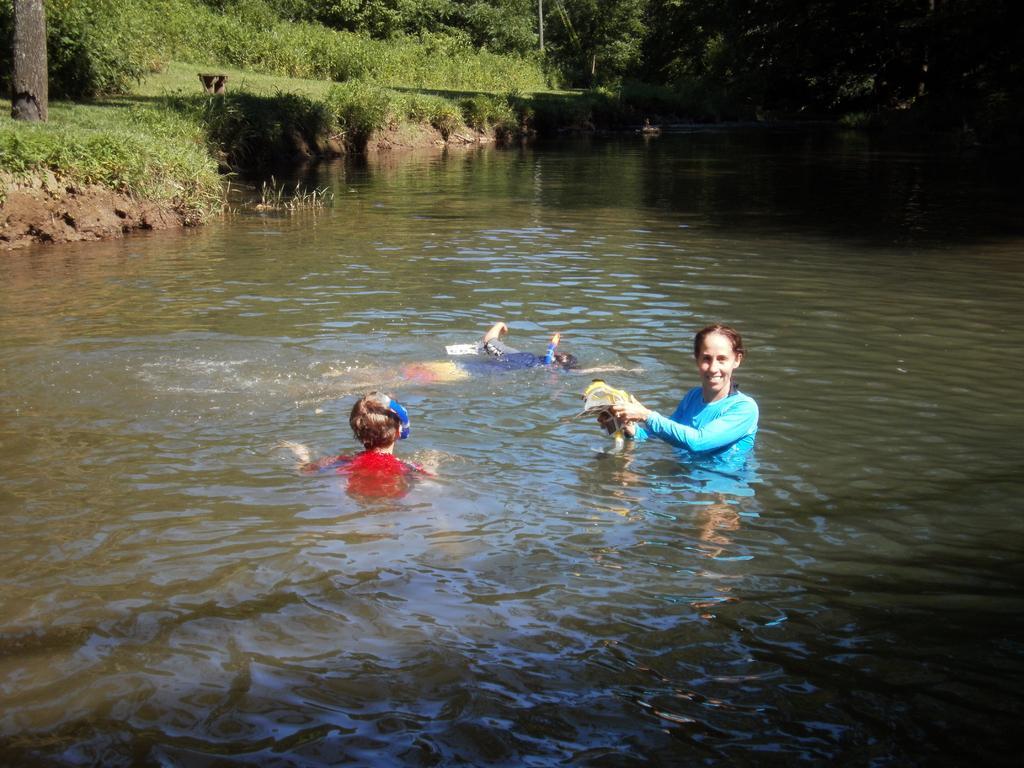Describe this image in one or two sentences. In the background we can see the trees, plants, grass. On the left side of the picture we can see a branch. In this picture we can see the water. We can see a person is swimming in the water. We can see a woman is holding an object. We can see a child. 